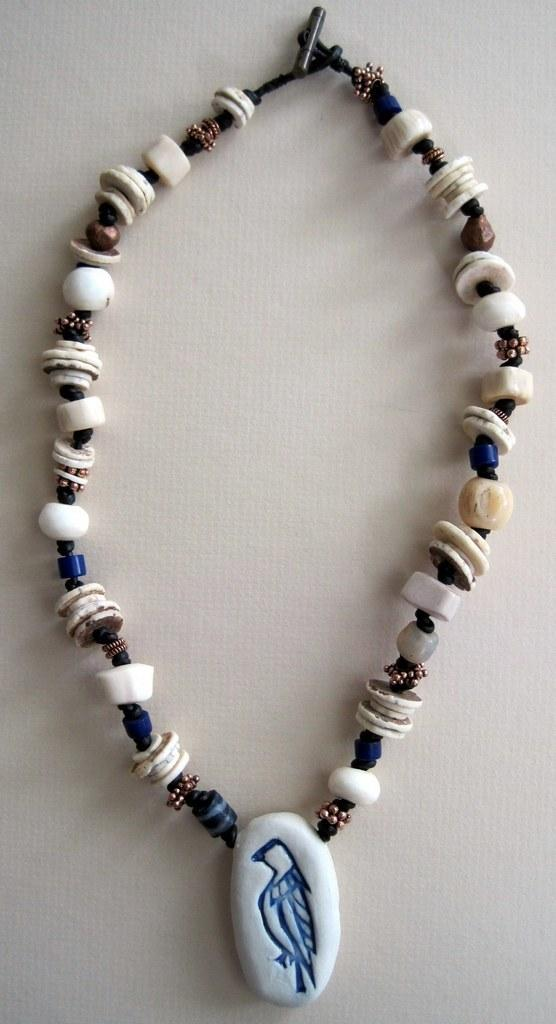What is the main object in the image? There is a necklace in the image. Where is the necklace placed? The necklace is on a platform. What type of bed is visible in the image? There is no bed present in the image; it only features a necklace on a platform. What is the weather like in the image? The image does not provide any information about the weather, as it only shows a necklace on a platform. 